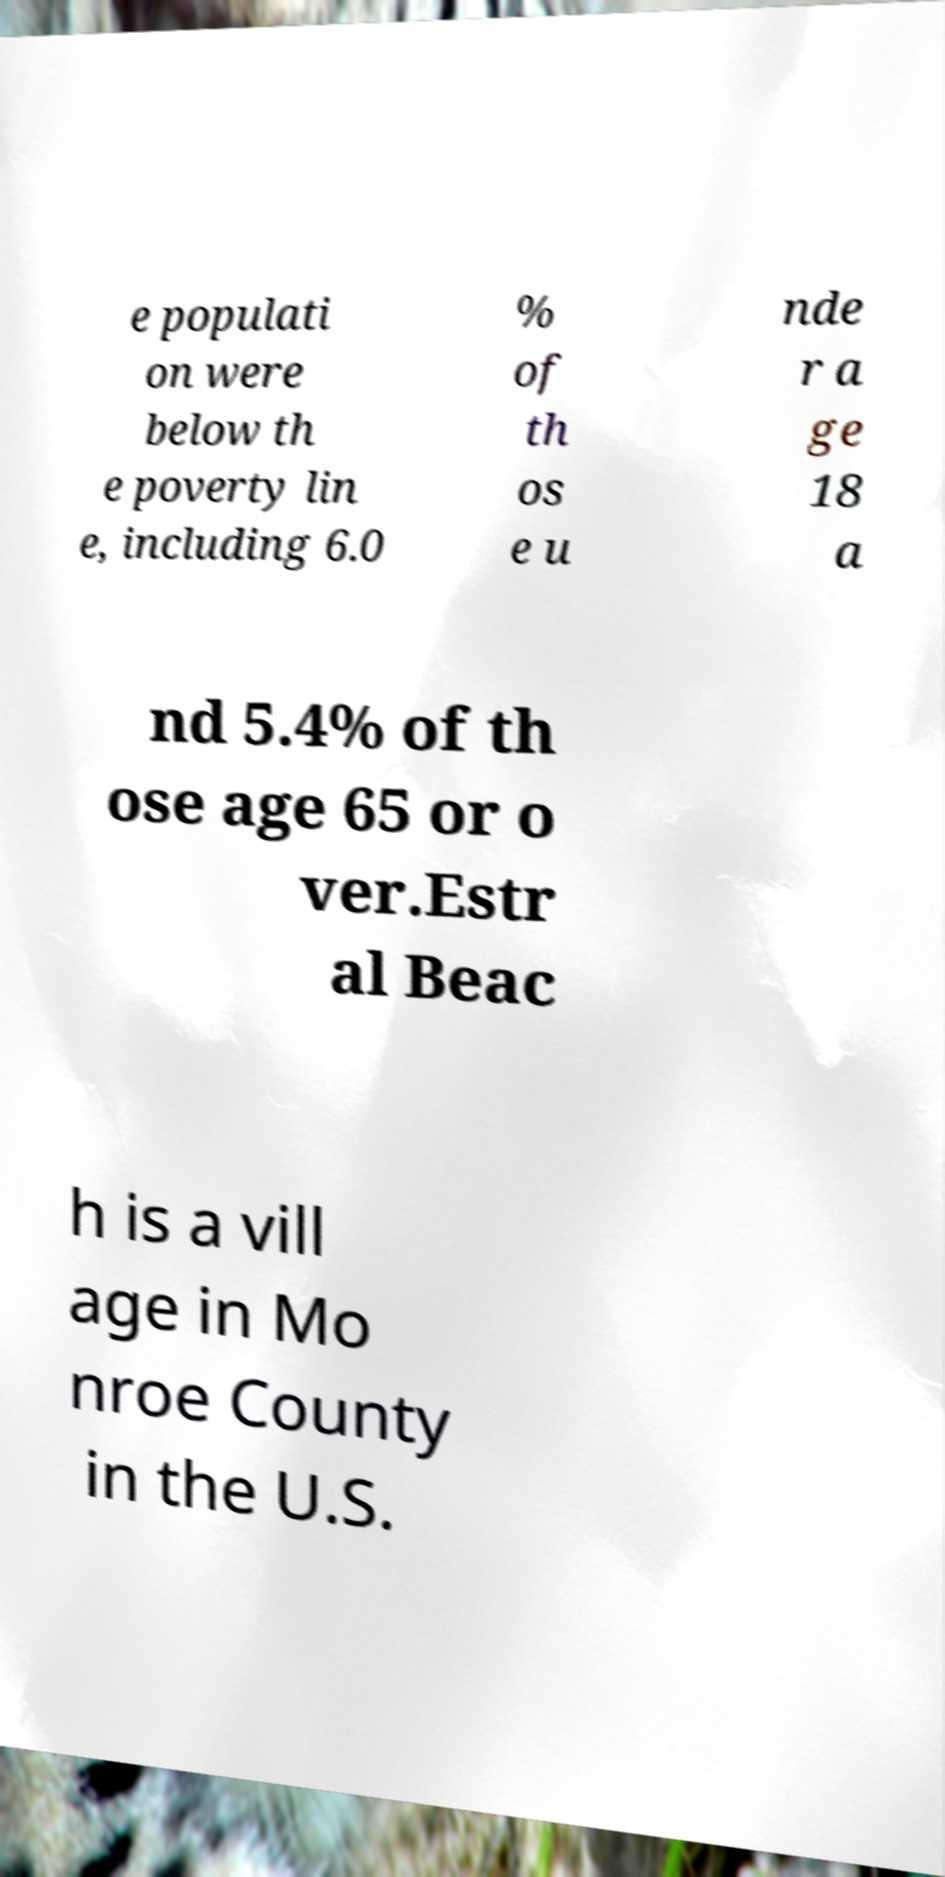Please read and relay the text visible in this image. What does it say? e populati on were below th e poverty lin e, including 6.0 % of th os e u nde r a ge 18 a nd 5.4% of th ose age 65 or o ver.Estr al Beac h is a vill age in Mo nroe County in the U.S. 